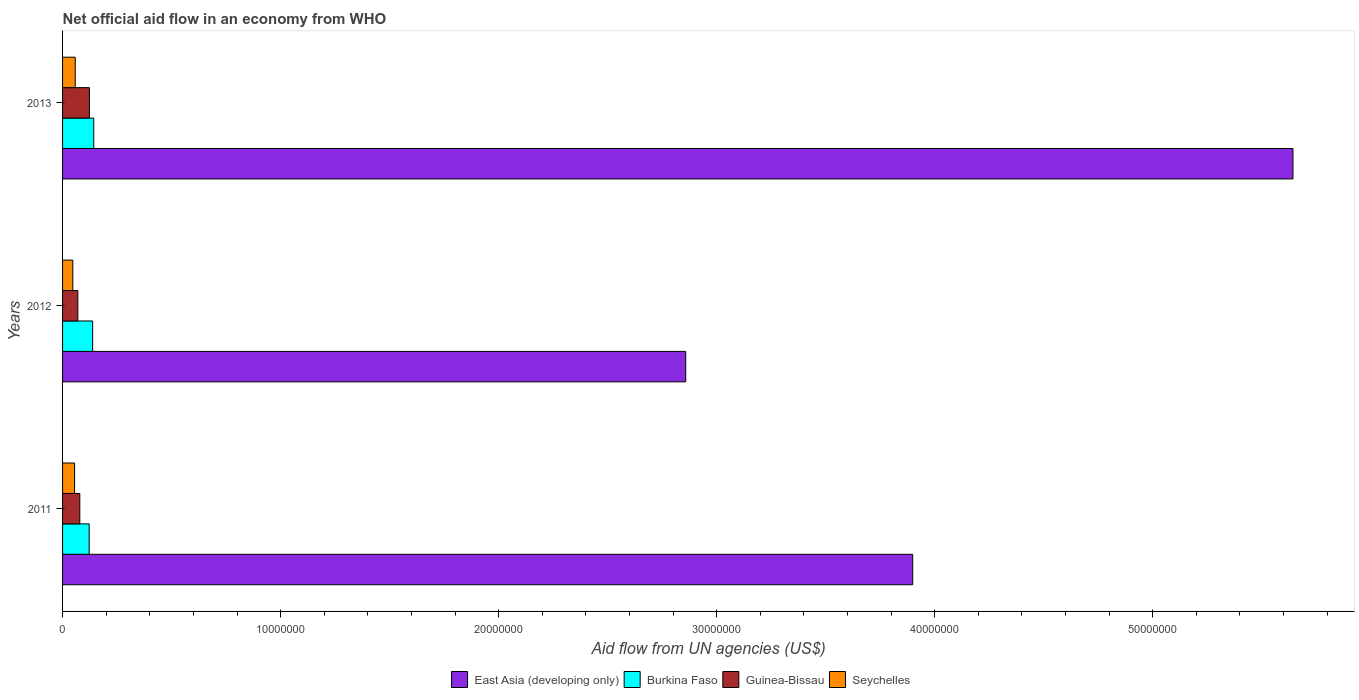What is the net official aid flow in Burkina Faso in 2012?
Offer a very short reply. 1.38e+06. Across all years, what is the maximum net official aid flow in Burkina Faso?
Provide a succinct answer. 1.43e+06. Across all years, what is the minimum net official aid flow in East Asia (developing only)?
Give a very brief answer. 2.86e+07. In which year was the net official aid flow in East Asia (developing only) maximum?
Offer a very short reply. 2013. What is the total net official aid flow in East Asia (developing only) in the graph?
Provide a succinct answer. 1.24e+08. What is the difference between the net official aid flow in Seychelles in 2011 and that in 2013?
Give a very brief answer. -3.00e+04. What is the difference between the net official aid flow in Guinea-Bissau in 2011 and the net official aid flow in Seychelles in 2012?
Your answer should be very brief. 3.20e+05. What is the average net official aid flow in Burkina Faso per year?
Keep it short and to the point. 1.34e+06. In the year 2011, what is the difference between the net official aid flow in Burkina Faso and net official aid flow in Guinea-Bissau?
Offer a very short reply. 4.30e+05. In how many years, is the net official aid flow in Seychelles greater than 28000000 US$?
Provide a short and direct response. 0. What is the ratio of the net official aid flow in Burkina Faso in 2011 to that in 2012?
Give a very brief answer. 0.88. Is the difference between the net official aid flow in Burkina Faso in 2011 and 2012 greater than the difference between the net official aid flow in Guinea-Bissau in 2011 and 2012?
Ensure brevity in your answer.  No. What is the difference between the highest and the second highest net official aid flow in East Asia (developing only)?
Offer a terse response. 1.74e+07. What is the difference between the highest and the lowest net official aid flow in East Asia (developing only)?
Your answer should be very brief. 2.78e+07. In how many years, is the net official aid flow in Guinea-Bissau greater than the average net official aid flow in Guinea-Bissau taken over all years?
Ensure brevity in your answer.  1. Is the sum of the net official aid flow in Seychelles in 2011 and 2013 greater than the maximum net official aid flow in Burkina Faso across all years?
Keep it short and to the point. No. Is it the case that in every year, the sum of the net official aid flow in East Asia (developing only) and net official aid flow in Guinea-Bissau is greater than the sum of net official aid flow in Burkina Faso and net official aid flow in Seychelles?
Ensure brevity in your answer.  Yes. What does the 3rd bar from the top in 2013 represents?
Offer a very short reply. Burkina Faso. What does the 4th bar from the bottom in 2012 represents?
Your answer should be compact. Seychelles. Is it the case that in every year, the sum of the net official aid flow in Seychelles and net official aid flow in Burkina Faso is greater than the net official aid flow in Guinea-Bissau?
Offer a terse response. Yes. Are all the bars in the graph horizontal?
Keep it short and to the point. Yes. What is the difference between two consecutive major ticks on the X-axis?
Provide a succinct answer. 1.00e+07. Are the values on the major ticks of X-axis written in scientific E-notation?
Give a very brief answer. No. Does the graph contain any zero values?
Offer a very short reply. No. Where does the legend appear in the graph?
Make the answer very short. Bottom center. How many legend labels are there?
Provide a short and direct response. 4. What is the title of the graph?
Your answer should be compact. Net official aid flow in an economy from WHO. Does "Namibia" appear as one of the legend labels in the graph?
Your answer should be compact. No. What is the label or title of the X-axis?
Provide a succinct answer. Aid flow from UN agencies (US$). What is the Aid flow from UN agencies (US$) in East Asia (developing only) in 2011?
Your answer should be compact. 3.90e+07. What is the Aid flow from UN agencies (US$) in Burkina Faso in 2011?
Your answer should be compact. 1.22e+06. What is the Aid flow from UN agencies (US$) in Guinea-Bissau in 2011?
Ensure brevity in your answer.  7.90e+05. What is the Aid flow from UN agencies (US$) of Seychelles in 2011?
Give a very brief answer. 5.50e+05. What is the Aid flow from UN agencies (US$) of East Asia (developing only) in 2012?
Give a very brief answer. 2.86e+07. What is the Aid flow from UN agencies (US$) of Burkina Faso in 2012?
Make the answer very short. 1.38e+06. What is the Aid flow from UN agencies (US$) in Seychelles in 2012?
Offer a very short reply. 4.70e+05. What is the Aid flow from UN agencies (US$) in East Asia (developing only) in 2013?
Give a very brief answer. 5.64e+07. What is the Aid flow from UN agencies (US$) in Burkina Faso in 2013?
Make the answer very short. 1.43e+06. What is the Aid flow from UN agencies (US$) of Guinea-Bissau in 2013?
Offer a terse response. 1.23e+06. What is the Aid flow from UN agencies (US$) in Seychelles in 2013?
Make the answer very short. 5.80e+05. Across all years, what is the maximum Aid flow from UN agencies (US$) in East Asia (developing only)?
Ensure brevity in your answer.  5.64e+07. Across all years, what is the maximum Aid flow from UN agencies (US$) in Burkina Faso?
Give a very brief answer. 1.43e+06. Across all years, what is the maximum Aid flow from UN agencies (US$) of Guinea-Bissau?
Ensure brevity in your answer.  1.23e+06. Across all years, what is the maximum Aid flow from UN agencies (US$) of Seychelles?
Offer a terse response. 5.80e+05. Across all years, what is the minimum Aid flow from UN agencies (US$) of East Asia (developing only)?
Provide a short and direct response. 2.86e+07. Across all years, what is the minimum Aid flow from UN agencies (US$) of Burkina Faso?
Offer a terse response. 1.22e+06. Across all years, what is the minimum Aid flow from UN agencies (US$) in Guinea-Bissau?
Your answer should be very brief. 7.00e+05. Across all years, what is the minimum Aid flow from UN agencies (US$) of Seychelles?
Your response must be concise. 4.70e+05. What is the total Aid flow from UN agencies (US$) of East Asia (developing only) in the graph?
Provide a short and direct response. 1.24e+08. What is the total Aid flow from UN agencies (US$) in Burkina Faso in the graph?
Your answer should be compact. 4.03e+06. What is the total Aid flow from UN agencies (US$) of Guinea-Bissau in the graph?
Offer a terse response. 2.72e+06. What is the total Aid flow from UN agencies (US$) in Seychelles in the graph?
Your answer should be compact. 1.60e+06. What is the difference between the Aid flow from UN agencies (US$) of East Asia (developing only) in 2011 and that in 2012?
Offer a terse response. 1.04e+07. What is the difference between the Aid flow from UN agencies (US$) of Burkina Faso in 2011 and that in 2012?
Offer a very short reply. -1.60e+05. What is the difference between the Aid flow from UN agencies (US$) in Guinea-Bissau in 2011 and that in 2012?
Offer a terse response. 9.00e+04. What is the difference between the Aid flow from UN agencies (US$) of East Asia (developing only) in 2011 and that in 2013?
Your answer should be compact. -1.74e+07. What is the difference between the Aid flow from UN agencies (US$) of Guinea-Bissau in 2011 and that in 2013?
Offer a terse response. -4.40e+05. What is the difference between the Aid flow from UN agencies (US$) in Seychelles in 2011 and that in 2013?
Ensure brevity in your answer.  -3.00e+04. What is the difference between the Aid flow from UN agencies (US$) in East Asia (developing only) in 2012 and that in 2013?
Keep it short and to the point. -2.78e+07. What is the difference between the Aid flow from UN agencies (US$) of Burkina Faso in 2012 and that in 2013?
Provide a short and direct response. -5.00e+04. What is the difference between the Aid flow from UN agencies (US$) in Guinea-Bissau in 2012 and that in 2013?
Provide a succinct answer. -5.30e+05. What is the difference between the Aid flow from UN agencies (US$) of Seychelles in 2012 and that in 2013?
Provide a succinct answer. -1.10e+05. What is the difference between the Aid flow from UN agencies (US$) of East Asia (developing only) in 2011 and the Aid flow from UN agencies (US$) of Burkina Faso in 2012?
Offer a very short reply. 3.76e+07. What is the difference between the Aid flow from UN agencies (US$) of East Asia (developing only) in 2011 and the Aid flow from UN agencies (US$) of Guinea-Bissau in 2012?
Your answer should be very brief. 3.83e+07. What is the difference between the Aid flow from UN agencies (US$) of East Asia (developing only) in 2011 and the Aid flow from UN agencies (US$) of Seychelles in 2012?
Ensure brevity in your answer.  3.85e+07. What is the difference between the Aid flow from UN agencies (US$) of Burkina Faso in 2011 and the Aid flow from UN agencies (US$) of Guinea-Bissau in 2012?
Offer a very short reply. 5.20e+05. What is the difference between the Aid flow from UN agencies (US$) in Burkina Faso in 2011 and the Aid flow from UN agencies (US$) in Seychelles in 2012?
Your answer should be compact. 7.50e+05. What is the difference between the Aid flow from UN agencies (US$) in East Asia (developing only) in 2011 and the Aid flow from UN agencies (US$) in Burkina Faso in 2013?
Your response must be concise. 3.76e+07. What is the difference between the Aid flow from UN agencies (US$) of East Asia (developing only) in 2011 and the Aid flow from UN agencies (US$) of Guinea-Bissau in 2013?
Your response must be concise. 3.78e+07. What is the difference between the Aid flow from UN agencies (US$) of East Asia (developing only) in 2011 and the Aid flow from UN agencies (US$) of Seychelles in 2013?
Make the answer very short. 3.84e+07. What is the difference between the Aid flow from UN agencies (US$) of Burkina Faso in 2011 and the Aid flow from UN agencies (US$) of Guinea-Bissau in 2013?
Your answer should be very brief. -10000. What is the difference between the Aid flow from UN agencies (US$) in Burkina Faso in 2011 and the Aid flow from UN agencies (US$) in Seychelles in 2013?
Make the answer very short. 6.40e+05. What is the difference between the Aid flow from UN agencies (US$) in East Asia (developing only) in 2012 and the Aid flow from UN agencies (US$) in Burkina Faso in 2013?
Keep it short and to the point. 2.72e+07. What is the difference between the Aid flow from UN agencies (US$) of East Asia (developing only) in 2012 and the Aid flow from UN agencies (US$) of Guinea-Bissau in 2013?
Offer a terse response. 2.74e+07. What is the difference between the Aid flow from UN agencies (US$) of East Asia (developing only) in 2012 and the Aid flow from UN agencies (US$) of Seychelles in 2013?
Your response must be concise. 2.80e+07. What is the difference between the Aid flow from UN agencies (US$) in Burkina Faso in 2012 and the Aid flow from UN agencies (US$) in Guinea-Bissau in 2013?
Offer a very short reply. 1.50e+05. What is the difference between the Aid flow from UN agencies (US$) in Burkina Faso in 2012 and the Aid flow from UN agencies (US$) in Seychelles in 2013?
Ensure brevity in your answer.  8.00e+05. What is the average Aid flow from UN agencies (US$) of East Asia (developing only) per year?
Your answer should be compact. 4.13e+07. What is the average Aid flow from UN agencies (US$) of Burkina Faso per year?
Ensure brevity in your answer.  1.34e+06. What is the average Aid flow from UN agencies (US$) of Guinea-Bissau per year?
Keep it short and to the point. 9.07e+05. What is the average Aid flow from UN agencies (US$) in Seychelles per year?
Give a very brief answer. 5.33e+05. In the year 2011, what is the difference between the Aid flow from UN agencies (US$) of East Asia (developing only) and Aid flow from UN agencies (US$) of Burkina Faso?
Make the answer very short. 3.78e+07. In the year 2011, what is the difference between the Aid flow from UN agencies (US$) of East Asia (developing only) and Aid flow from UN agencies (US$) of Guinea-Bissau?
Keep it short and to the point. 3.82e+07. In the year 2011, what is the difference between the Aid flow from UN agencies (US$) of East Asia (developing only) and Aid flow from UN agencies (US$) of Seychelles?
Your answer should be very brief. 3.84e+07. In the year 2011, what is the difference between the Aid flow from UN agencies (US$) of Burkina Faso and Aid flow from UN agencies (US$) of Seychelles?
Ensure brevity in your answer.  6.70e+05. In the year 2011, what is the difference between the Aid flow from UN agencies (US$) of Guinea-Bissau and Aid flow from UN agencies (US$) of Seychelles?
Provide a succinct answer. 2.40e+05. In the year 2012, what is the difference between the Aid flow from UN agencies (US$) in East Asia (developing only) and Aid flow from UN agencies (US$) in Burkina Faso?
Your response must be concise. 2.72e+07. In the year 2012, what is the difference between the Aid flow from UN agencies (US$) of East Asia (developing only) and Aid flow from UN agencies (US$) of Guinea-Bissau?
Offer a terse response. 2.79e+07. In the year 2012, what is the difference between the Aid flow from UN agencies (US$) of East Asia (developing only) and Aid flow from UN agencies (US$) of Seychelles?
Keep it short and to the point. 2.81e+07. In the year 2012, what is the difference between the Aid flow from UN agencies (US$) in Burkina Faso and Aid flow from UN agencies (US$) in Guinea-Bissau?
Your answer should be very brief. 6.80e+05. In the year 2012, what is the difference between the Aid flow from UN agencies (US$) in Burkina Faso and Aid flow from UN agencies (US$) in Seychelles?
Provide a succinct answer. 9.10e+05. In the year 2013, what is the difference between the Aid flow from UN agencies (US$) in East Asia (developing only) and Aid flow from UN agencies (US$) in Burkina Faso?
Make the answer very short. 5.50e+07. In the year 2013, what is the difference between the Aid flow from UN agencies (US$) in East Asia (developing only) and Aid flow from UN agencies (US$) in Guinea-Bissau?
Your answer should be compact. 5.52e+07. In the year 2013, what is the difference between the Aid flow from UN agencies (US$) in East Asia (developing only) and Aid flow from UN agencies (US$) in Seychelles?
Provide a succinct answer. 5.58e+07. In the year 2013, what is the difference between the Aid flow from UN agencies (US$) of Burkina Faso and Aid flow from UN agencies (US$) of Seychelles?
Keep it short and to the point. 8.50e+05. In the year 2013, what is the difference between the Aid flow from UN agencies (US$) of Guinea-Bissau and Aid flow from UN agencies (US$) of Seychelles?
Your answer should be compact. 6.50e+05. What is the ratio of the Aid flow from UN agencies (US$) of East Asia (developing only) in 2011 to that in 2012?
Your answer should be very brief. 1.36. What is the ratio of the Aid flow from UN agencies (US$) in Burkina Faso in 2011 to that in 2012?
Provide a short and direct response. 0.88. What is the ratio of the Aid flow from UN agencies (US$) in Guinea-Bissau in 2011 to that in 2012?
Make the answer very short. 1.13. What is the ratio of the Aid flow from UN agencies (US$) in Seychelles in 2011 to that in 2012?
Give a very brief answer. 1.17. What is the ratio of the Aid flow from UN agencies (US$) of East Asia (developing only) in 2011 to that in 2013?
Provide a succinct answer. 0.69. What is the ratio of the Aid flow from UN agencies (US$) in Burkina Faso in 2011 to that in 2013?
Provide a short and direct response. 0.85. What is the ratio of the Aid flow from UN agencies (US$) of Guinea-Bissau in 2011 to that in 2013?
Ensure brevity in your answer.  0.64. What is the ratio of the Aid flow from UN agencies (US$) of Seychelles in 2011 to that in 2013?
Your answer should be compact. 0.95. What is the ratio of the Aid flow from UN agencies (US$) in East Asia (developing only) in 2012 to that in 2013?
Give a very brief answer. 0.51. What is the ratio of the Aid flow from UN agencies (US$) in Guinea-Bissau in 2012 to that in 2013?
Provide a succinct answer. 0.57. What is the ratio of the Aid flow from UN agencies (US$) in Seychelles in 2012 to that in 2013?
Offer a very short reply. 0.81. What is the difference between the highest and the second highest Aid flow from UN agencies (US$) of East Asia (developing only)?
Ensure brevity in your answer.  1.74e+07. What is the difference between the highest and the second highest Aid flow from UN agencies (US$) of Burkina Faso?
Provide a succinct answer. 5.00e+04. What is the difference between the highest and the second highest Aid flow from UN agencies (US$) of Seychelles?
Give a very brief answer. 3.00e+04. What is the difference between the highest and the lowest Aid flow from UN agencies (US$) of East Asia (developing only)?
Keep it short and to the point. 2.78e+07. What is the difference between the highest and the lowest Aid flow from UN agencies (US$) of Guinea-Bissau?
Your answer should be very brief. 5.30e+05. What is the difference between the highest and the lowest Aid flow from UN agencies (US$) of Seychelles?
Give a very brief answer. 1.10e+05. 